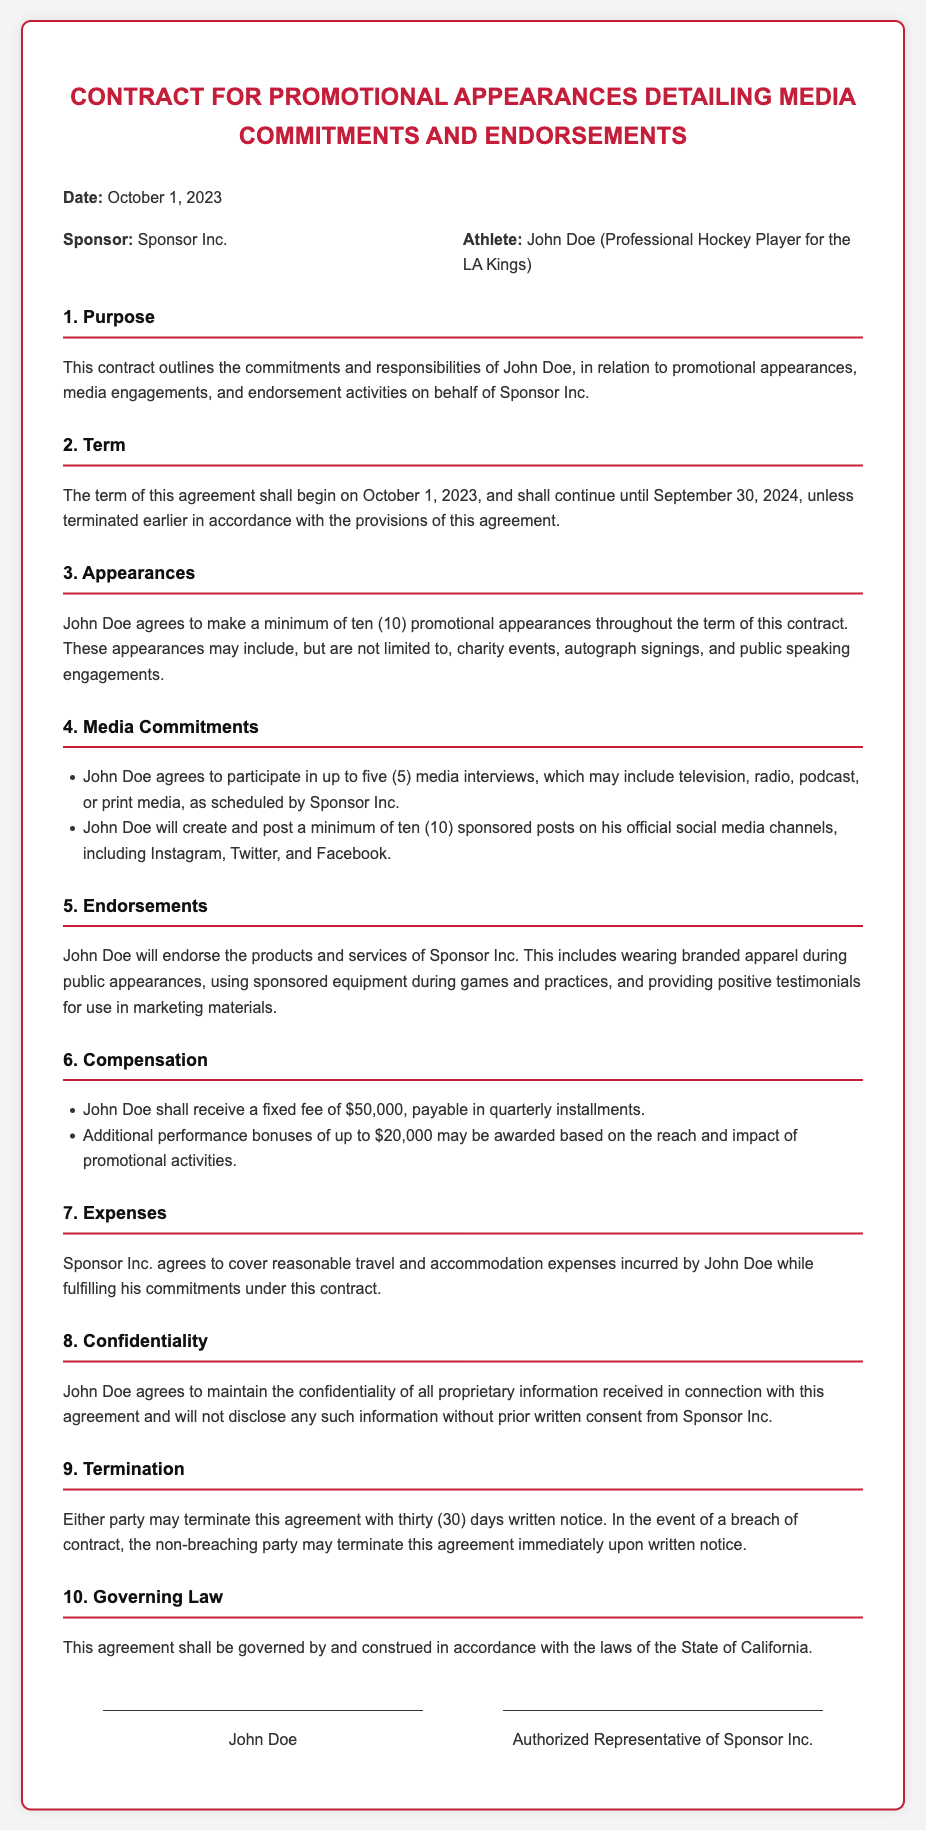What is the date of the contract? The date of the contract is specified in the document as October 1, 2023.
Answer: October 1, 2023 Who is the sponsor of the contract? The name of the sponsor is listed in the document under the parties section as Sponsor Inc.
Answer: Sponsor Inc How many promotional appearances must John Doe make? The minimum number of appearances required from John Doe is stated in the appearances section of the document.
Answer: ten (10) What is the fixed fee John Doe will receive? The fixed fee is specified in the compensation section of the document.
Answer: $50,000 What is the duration of the contract? The term of the contract is outlined in the term section as starting and ending dates.
Answer: October 1, 2023, to September 30, 2024 How many media interviews is John Doe required to participate in? The number of media interviews John Doe must participate in is mentioned in the media commitments section.
Answer: five (5) What is the governing law for this contract? The governing law is specified in the governing law section of the document.
Answer: State of California What happens if either party breaches the contract? The document states the consequences for a breach of contract in the termination section.
Answer: Immediate termination 